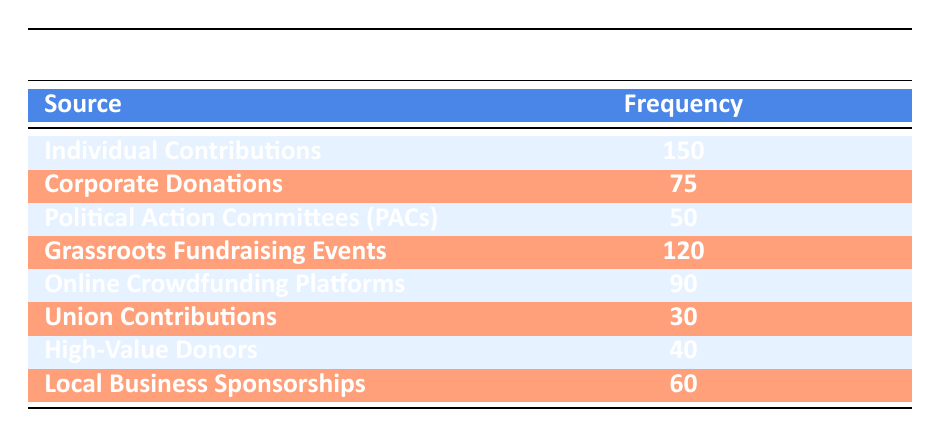What is the frequency of Individual Contributions? The table lists the frequency of Individual Contributions as 150.
Answer: 150 Which source of donations had the lowest frequency? By examining the table, Union Contributions is listed as having the lowest frequency, which is 30.
Answer: Union Contributions What is the total frequency of donations from Corporate Donations and Political Action Committees (PACs)? To find the total frequency, we add the frequency of Corporate Donations (75) and Political Action Committees (PACs) (50): 75 + 50 = 125.
Answer: 125 Is the frequency of donations from Grassroots Fundraising Events greater than that from Online Crowdfunding Platforms? Grassroots Fundraising Events has a frequency of 120, while Online Crowdfunding Platforms has a frequency of 90. Since 120 is greater than 90, the statement is true.
Answer: Yes What is the average frequency of donations from the sources listed in the table? To calculate the average frequency, we first sum all the frequencies (150 + 75 + 50 + 120 + 90 + 30 + 40 + 60 = 615), and then divide by the number of sources (8): 615 ÷ 8 = 76.875.
Answer: 76.875 If we remove the two sources with the highest frequencies, what is the total frequency of the remaining sources? The two highest frequencies are from Individual Contributions (150) and Grassroots Fundraising Events (120). Removing these gives us 75 + 50 + 90 + 30 + 40 + 60 = 345 as the total frequency of the remaining sources.
Answer: 345 Are there any sources that received fewer than 50 donations? By checking the frequencies, Union Contributions (30) and Political Action Committees (PACs) (50) both received fewer than 50 (exactly 30). Therefore, the statement is true.
Answer: Yes What is the difference in frequency between Online Crowdfunding Platforms and Local Business Sponsorships? Online Crowdfunding Platforms has a frequency of 90 and Local Business Sponsorships has a frequency of 60. The difference is 90 - 60 = 30.
Answer: 30 How many sources received a frequency above 70? The sources with frequencies above 70 are: Individual Contributions (150), Grassroots Fundraising Events (120), Online Crowdfunding Platforms (90), and Corporate Donations (75), totaling 4 sources.
Answer: 4 